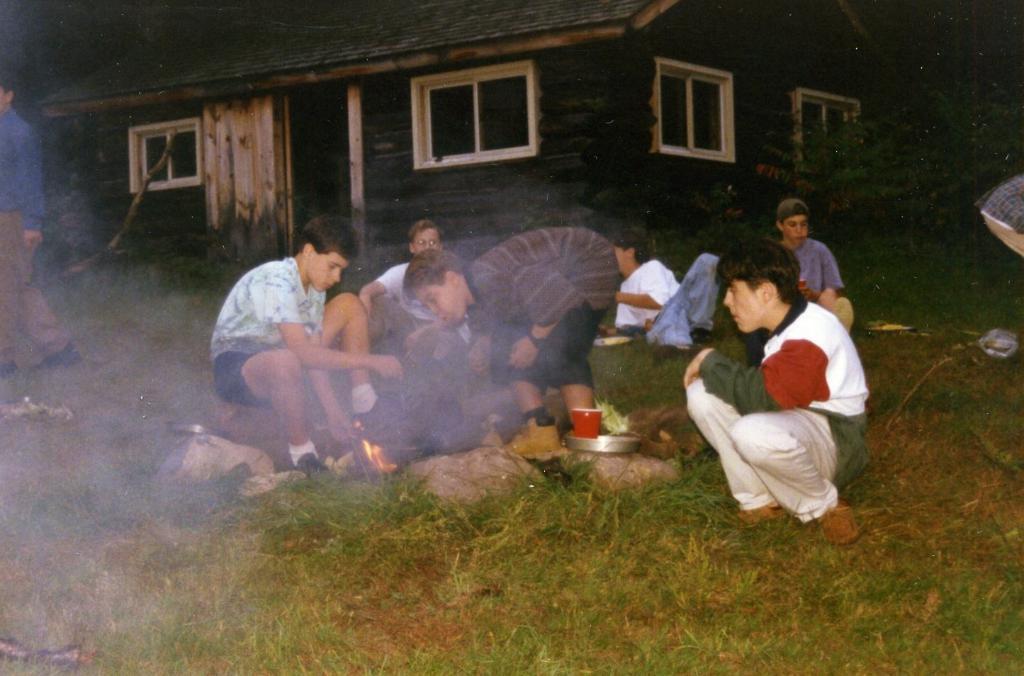Could you give a brief overview of what you see in this image? In this picture there are two persons sitting on a greenery ground and there is a fire in between them and there is another person blowing towards the fire and there are few other people and a house in the background and there is a person standing in the left corner. 